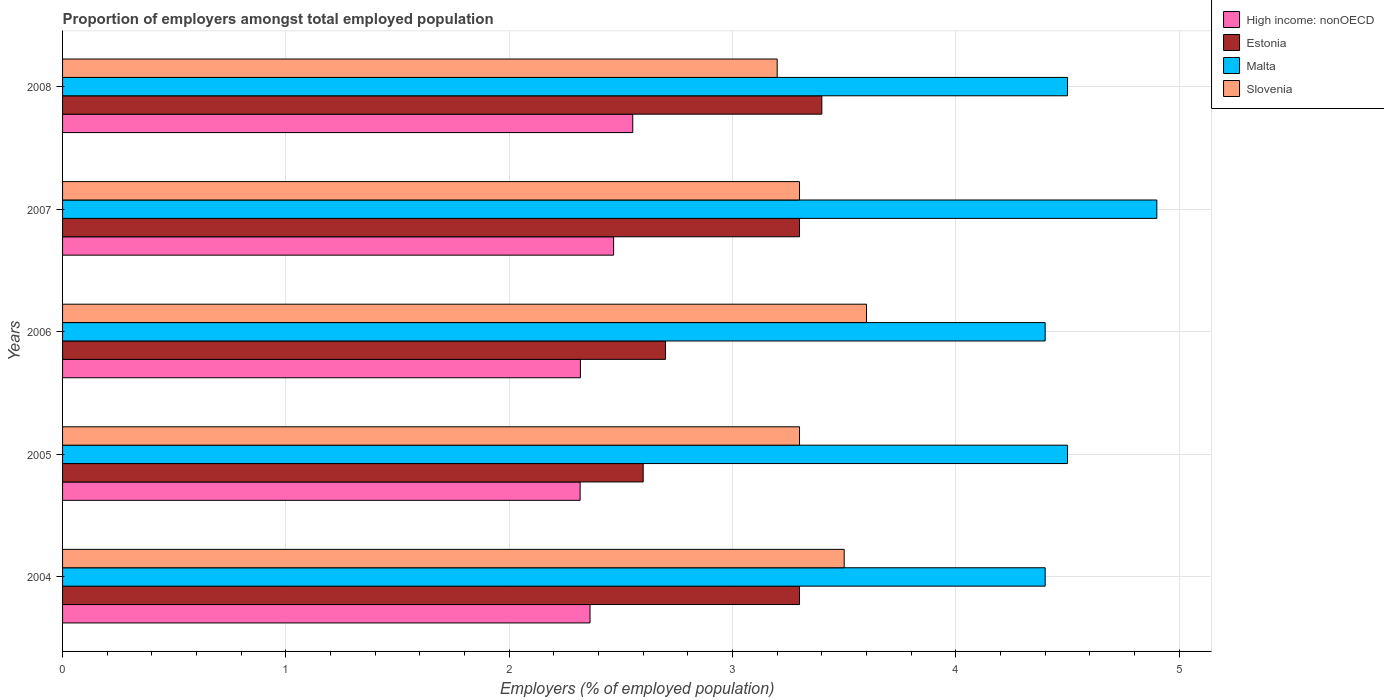Are the number of bars per tick equal to the number of legend labels?
Provide a short and direct response. Yes. Are the number of bars on each tick of the Y-axis equal?
Your answer should be very brief. Yes. How many bars are there on the 3rd tick from the top?
Offer a very short reply. 4. What is the label of the 5th group of bars from the top?
Make the answer very short. 2004. What is the proportion of employers in Slovenia in 2007?
Your response must be concise. 3.3. Across all years, what is the maximum proportion of employers in Estonia?
Offer a very short reply. 3.4. Across all years, what is the minimum proportion of employers in Slovenia?
Ensure brevity in your answer.  3.2. What is the total proportion of employers in Slovenia in the graph?
Give a very brief answer. 16.9. What is the difference between the proportion of employers in Slovenia in 2005 and that in 2008?
Make the answer very short. 0.1. What is the difference between the proportion of employers in Malta in 2008 and the proportion of employers in Estonia in 2007?
Your answer should be compact. 1.2. What is the average proportion of employers in Estonia per year?
Give a very brief answer. 3.06. In the year 2004, what is the difference between the proportion of employers in High income: nonOECD and proportion of employers in Estonia?
Provide a short and direct response. -0.94. In how many years, is the proportion of employers in Malta greater than 4 %?
Offer a terse response. 5. What is the ratio of the proportion of employers in Estonia in 2006 to that in 2007?
Make the answer very short. 0.82. Is the difference between the proportion of employers in High income: nonOECD in 2007 and 2008 greater than the difference between the proportion of employers in Estonia in 2007 and 2008?
Offer a terse response. Yes. What is the difference between the highest and the second highest proportion of employers in Malta?
Provide a succinct answer. 0.4. What is the difference between the highest and the lowest proportion of employers in Estonia?
Provide a succinct answer. 0.8. Is the sum of the proportion of employers in Malta in 2004 and 2007 greater than the maximum proportion of employers in Slovenia across all years?
Provide a short and direct response. Yes. What does the 2nd bar from the top in 2007 represents?
Provide a succinct answer. Malta. What does the 4th bar from the bottom in 2008 represents?
Keep it short and to the point. Slovenia. How many bars are there?
Provide a succinct answer. 20. What is the difference between two consecutive major ticks on the X-axis?
Provide a succinct answer. 1. Are the values on the major ticks of X-axis written in scientific E-notation?
Your answer should be compact. No. Does the graph contain grids?
Keep it short and to the point. Yes. Where does the legend appear in the graph?
Offer a terse response. Top right. How many legend labels are there?
Your answer should be very brief. 4. How are the legend labels stacked?
Your answer should be very brief. Vertical. What is the title of the graph?
Offer a terse response. Proportion of employers amongst total employed population. What is the label or title of the X-axis?
Offer a terse response. Employers (% of employed population). What is the Employers (% of employed population) in High income: nonOECD in 2004?
Your answer should be very brief. 2.36. What is the Employers (% of employed population) in Estonia in 2004?
Provide a short and direct response. 3.3. What is the Employers (% of employed population) of Malta in 2004?
Offer a very short reply. 4.4. What is the Employers (% of employed population) of High income: nonOECD in 2005?
Give a very brief answer. 2.32. What is the Employers (% of employed population) of Estonia in 2005?
Give a very brief answer. 2.6. What is the Employers (% of employed population) in Slovenia in 2005?
Offer a very short reply. 3.3. What is the Employers (% of employed population) in High income: nonOECD in 2006?
Keep it short and to the point. 2.32. What is the Employers (% of employed population) in Estonia in 2006?
Your answer should be compact. 2.7. What is the Employers (% of employed population) in Malta in 2006?
Your answer should be very brief. 4.4. What is the Employers (% of employed population) of Slovenia in 2006?
Make the answer very short. 3.6. What is the Employers (% of employed population) in High income: nonOECD in 2007?
Offer a very short reply. 2.47. What is the Employers (% of employed population) in Estonia in 2007?
Provide a short and direct response. 3.3. What is the Employers (% of employed population) of Malta in 2007?
Make the answer very short. 4.9. What is the Employers (% of employed population) in Slovenia in 2007?
Make the answer very short. 3.3. What is the Employers (% of employed population) of High income: nonOECD in 2008?
Your answer should be very brief. 2.55. What is the Employers (% of employed population) of Estonia in 2008?
Your answer should be compact. 3.4. What is the Employers (% of employed population) of Malta in 2008?
Make the answer very short. 4.5. What is the Employers (% of employed population) in Slovenia in 2008?
Give a very brief answer. 3.2. Across all years, what is the maximum Employers (% of employed population) in High income: nonOECD?
Your answer should be very brief. 2.55. Across all years, what is the maximum Employers (% of employed population) in Estonia?
Your response must be concise. 3.4. Across all years, what is the maximum Employers (% of employed population) of Malta?
Your response must be concise. 4.9. Across all years, what is the maximum Employers (% of employed population) in Slovenia?
Your answer should be very brief. 3.6. Across all years, what is the minimum Employers (% of employed population) in High income: nonOECD?
Keep it short and to the point. 2.32. Across all years, what is the minimum Employers (% of employed population) of Estonia?
Offer a very short reply. 2.6. Across all years, what is the minimum Employers (% of employed population) of Malta?
Your answer should be compact. 4.4. Across all years, what is the minimum Employers (% of employed population) in Slovenia?
Make the answer very short. 3.2. What is the total Employers (% of employed population) of High income: nonOECD in the graph?
Make the answer very short. 12.02. What is the total Employers (% of employed population) of Malta in the graph?
Your response must be concise. 22.7. What is the total Employers (% of employed population) in Slovenia in the graph?
Offer a very short reply. 16.9. What is the difference between the Employers (% of employed population) of High income: nonOECD in 2004 and that in 2005?
Ensure brevity in your answer.  0.04. What is the difference between the Employers (% of employed population) in Estonia in 2004 and that in 2005?
Offer a terse response. 0.7. What is the difference between the Employers (% of employed population) of Slovenia in 2004 and that in 2005?
Offer a terse response. 0.2. What is the difference between the Employers (% of employed population) in High income: nonOECD in 2004 and that in 2006?
Ensure brevity in your answer.  0.04. What is the difference between the Employers (% of employed population) in Malta in 2004 and that in 2006?
Your answer should be very brief. 0. What is the difference between the Employers (% of employed population) of High income: nonOECD in 2004 and that in 2007?
Offer a very short reply. -0.11. What is the difference between the Employers (% of employed population) in Slovenia in 2004 and that in 2007?
Your answer should be very brief. 0.2. What is the difference between the Employers (% of employed population) in High income: nonOECD in 2004 and that in 2008?
Give a very brief answer. -0.19. What is the difference between the Employers (% of employed population) in Malta in 2004 and that in 2008?
Provide a succinct answer. -0.1. What is the difference between the Employers (% of employed population) in Slovenia in 2004 and that in 2008?
Provide a succinct answer. 0.3. What is the difference between the Employers (% of employed population) of High income: nonOECD in 2005 and that in 2006?
Your response must be concise. -0. What is the difference between the Employers (% of employed population) of Estonia in 2005 and that in 2006?
Give a very brief answer. -0.1. What is the difference between the Employers (% of employed population) of Slovenia in 2005 and that in 2006?
Provide a succinct answer. -0.3. What is the difference between the Employers (% of employed population) of High income: nonOECD in 2005 and that in 2007?
Keep it short and to the point. -0.15. What is the difference between the Employers (% of employed population) in Slovenia in 2005 and that in 2007?
Provide a succinct answer. 0. What is the difference between the Employers (% of employed population) of High income: nonOECD in 2005 and that in 2008?
Offer a very short reply. -0.24. What is the difference between the Employers (% of employed population) of Malta in 2005 and that in 2008?
Offer a very short reply. 0. What is the difference between the Employers (% of employed population) of Slovenia in 2005 and that in 2008?
Keep it short and to the point. 0.1. What is the difference between the Employers (% of employed population) of High income: nonOECD in 2006 and that in 2007?
Keep it short and to the point. -0.15. What is the difference between the Employers (% of employed population) in Slovenia in 2006 and that in 2007?
Ensure brevity in your answer.  0.3. What is the difference between the Employers (% of employed population) of High income: nonOECD in 2006 and that in 2008?
Your response must be concise. -0.23. What is the difference between the Employers (% of employed population) in Estonia in 2006 and that in 2008?
Make the answer very short. -0.7. What is the difference between the Employers (% of employed population) of Malta in 2006 and that in 2008?
Ensure brevity in your answer.  -0.1. What is the difference between the Employers (% of employed population) of High income: nonOECD in 2007 and that in 2008?
Provide a succinct answer. -0.09. What is the difference between the Employers (% of employed population) of Malta in 2007 and that in 2008?
Keep it short and to the point. 0.4. What is the difference between the Employers (% of employed population) in Slovenia in 2007 and that in 2008?
Ensure brevity in your answer.  0.1. What is the difference between the Employers (% of employed population) in High income: nonOECD in 2004 and the Employers (% of employed population) in Estonia in 2005?
Offer a very short reply. -0.24. What is the difference between the Employers (% of employed population) in High income: nonOECD in 2004 and the Employers (% of employed population) in Malta in 2005?
Make the answer very short. -2.14. What is the difference between the Employers (% of employed population) in High income: nonOECD in 2004 and the Employers (% of employed population) in Slovenia in 2005?
Your answer should be very brief. -0.94. What is the difference between the Employers (% of employed population) of Estonia in 2004 and the Employers (% of employed population) of Slovenia in 2005?
Give a very brief answer. 0. What is the difference between the Employers (% of employed population) in High income: nonOECD in 2004 and the Employers (% of employed population) in Estonia in 2006?
Your response must be concise. -0.34. What is the difference between the Employers (% of employed population) in High income: nonOECD in 2004 and the Employers (% of employed population) in Malta in 2006?
Offer a very short reply. -2.04. What is the difference between the Employers (% of employed population) of High income: nonOECD in 2004 and the Employers (% of employed population) of Slovenia in 2006?
Offer a very short reply. -1.24. What is the difference between the Employers (% of employed population) in Estonia in 2004 and the Employers (% of employed population) in Malta in 2006?
Your response must be concise. -1.1. What is the difference between the Employers (% of employed population) of High income: nonOECD in 2004 and the Employers (% of employed population) of Estonia in 2007?
Ensure brevity in your answer.  -0.94. What is the difference between the Employers (% of employed population) of High income: nonOECD in 2004 and the Employers (% of employed population) of Malta in 2007?
Your answer should be very brief. -2.54. What is the difference between the Employers (% of employed population) in High income: nonOECD in 2004 and the Employers (% of employed population) in Slovenia in 2007?
Make the answer very short. -0.94. What is the difference between the Employers (% of employed population) in Estonia in 2004 and the Employers (% of employed population) in Malta in 2007?
Your answer should be very brief. -1.6. What is the difference between the Employers (% of employed population) in Malta in 2004 and the Employers (% of employed population) in Slovenia in 2007?
Offer a terse response. 1.1. What is the difference between the Employers (% of employed population) in High income: nonOECD in 2004 and the Employers (% of employed population) in Estonia in 2008?
Provide a succinct answer. -1.04. What is the difference between the Employers (% of employed population) in High income: nonOECD in 2004 and the Employers (% of employed population) in Malta in 2008?
Provide a short and direct response. -2.14. What is the difference between the Employers (% of employed population) in High income: nonOECD in 2004 and the Employers (% of employed population) in Slovenia in 2008?
Provide a succinct answer. -0.84. What is the difference between the Employers (% of employed population) of Estonia in 2004 and the Employers (% of employed population) of Slovenia in 2008?
Offer a very short reply. 0.1. What is the difference between the Employers (% of employed population) in High income: nonOECD in 2005 and the Employers (% of employed population) in Estonia in 2006?
Make the answer very short. -0.38. What is the difference between the Employers (% of employed population) in High income: nonOECD in 2005 and the Employers (% of employed population) in Malta in 2006?
Offer a terse response. -2.08. What is the difference between the Employers (% of employed population) in High income: nonOECD in 2005 and the Employers (% of employed population) in Slovenia in 2006?
Keep it short and to the point. -1.28. What is the difference between the Employers (% of employed population) of Estonia in 2005 and the Employers (% of employed population) of Slovenia in 2006?
Your answer should be very brief. -1. What is the difference between the Employers (% of employed population) of High income: nonOECD in 2005 and the Employers (% of employed population) of Estonia in 2007?
Ensure brevity in your answer.  -0.98. What is the difference between the Employers (% of employed population) in High income: nonOECD in 2005 and the Employers (% of employed population) in Malta in 2007?
Your answer should be very brief. -2.58. What is the difference between the Employers (% of employed population) of High income: nonOECD in 2005 and the Employers (% of employed population) of Slovenia in 2007?
Give a very brief answer. -0.98. What is the difference between the Employers (% of employed population) in Estonia in 2005 and the Employers (% of employed population) in Slovenia in 2007?
Ensure brevity in your answer.  -0.7. What is the difference between the Employers (% of employed population) of Malta in 2005 and the Employers (% of employed population) of Slovenia in 2007?
Offer a terse response. 1.2. What is the difference between the Employers (% of employed population) of High income: nonOECD in 2005 and the Employers (% of employed population) of Estonia in 2008?
Keep it short and to the point. -1.08. What is the difference between the Employers (% of employed population) of High income: nonOECD in 2005 and the Employers (% of employed population) of Malta in 2008?
Offer a terse response. -2.18. What is the difference between the Employers (% of employed population) of High income: nonOECD in 2005 and the Employers (% of employed population) of Slovenia in 2008?
Offer a very short reply. -0.88. What is the difference between the Employers (% of employed population) in Estonia in 2005 and the Employers (% of employed population) in Slovenia in 2008?
Keep it short and to the point. -0.6. What is the difference between the Employers (% of employed population) of High income: nonOECD in 2006 and the Employers (% of employed population) of Estonia in 2007?
Offer a terse response. -0.98. What is the difference between the Employers (% of employed population) of High income: nonOECD in 2006 and the Employers (% of employed population) of Malta in 2007?
Offer a very short reply. -2.58. What is the difference between the Employers (% of employed population) in High income: nonOECD in 2006 and the Employers (% of employed population) in Slovenia in 2007?
Ensure brevity in your answer.  -0.98. What is the difference between the Employers (% of employed population) of Estonia in 2006 and the Employers (% of employed population) of Malta in 2007?
Offer a terse response. -2.2. What is the difference between the Employers (% of employed population) of Estonia in 2006 and the Employers (% of employed population) of Slovenia in 2007?
Your response must be concise. -0.6. What is the difference between the Employers (% of employed population) in High income: nonOECD in 2006 and the Employers (% of employed population) in Estonia in 2008?
Your answer should be compact. -1.08. What is the difference between the Employers (% of employed population) of High income: nonOECD in 2006 and the Employers (% of employed population) of Malta in 2008?
Offer a terse response. -2.18. What is the difference between the Employers (% of employed population) in High income: nonOECD in 2006 and the Employers (% of employed population) in Slovenia in 2008?
Offer a very short reply. -0.88. What is the difference between the Employers (% of employed population) of Estonia in 2006 and the Employers (% of employed population) of Malta in 2008?
Your response must be concise. -1.8. What is the difference between the Employers (% of employed population) of Malta in 2006 and the Employers (% of employed population) of Slovenia in 2008?
Provide a succinct answer. 1.2. What is the difference between the Employers (% of employed population) in High income: nonOECD in 2007 and the Employers (% of employed population) in Estonia in 2008?
Provide a short and direct response. -0.93. What is the difference between the Employers (% of employed population) in High income: nonOECD in 2007 and the Employers (% of employed population) in Malta in 2008?
Make the answer very short. -2.03. What is the difference between the Employers (% of employed population) of High income: nonOECD in 2007 and the Employers (% of employed population) of Slovenia in 2008?
Make the answer very short. -0.73. What is the difference between the Employers (% of employed population) in Estonia in 2007 and the Employers (% of employed population) in Malta in 2008?
Make the answer very short. -1.2. What is the difference between the Employers (% of employed population) of Estonia in 2007 and the Employers (% of employed population) of Slovenia in 2008?
Give a very brief answer. 0.1. What is the difference between the Employers (% of employed population) in Malta in 2007 and the Employers (% of employed population) in Slovenia in 2008?
Keep it short and to the point. 1.7. What is the average Employers (% of employed population) of High income: nonOECD per year?
Keep it short and to the point. 2.4. What is the average Employers (% of employed population) of Estonia per year?
Your response must be concise. 3.06. What is the average Employers (% of employed population) of Malta per year?
Make the answer very short. 4.54. What is the average Employers (% of employed population) in Slovenia per year?
Provide a short and direct response. 3.38. In the year 2004, what is the difference between the Employers (% of employed population) of High income: nonOECD and Employers (% of employed population) of Estonia?
Make the answer very short. -0.94. In the year 2004, what is the difference between the Employers (% of employed population) of High income: nonOECD and Employers (% of employed population) of Malta?
Provide a succinct answer. -2.04. In the year 2004, what is the difference between the Employers (% of employed population) of High income: nonOECD and Employers (% of employed population) of Slovenia?
Your response must be concise. -1.14. In the year 2004, what is the difference between the Employers (% of employed population) of Estonia and Employers (% of employed population) of Malta?
Your answer should be very brief. -1.1. In the year 2005, what is the difference between the Employers (% of employed population) in High income: nonOECD and Employers (% of employed population) in Estonia?
Offer a terse response. -0.28. In the year 2005, what is the difference between the Employers (% of employed population) in High income: nonOECD and Employers (% of employed population) in Malta?
Your answer should be very brief. -2.18. In the year 2005, what is the difference between the Employers (% of employed population) in High income: nonOECD and Employers (% of employed population) in Slovenia?
Your response must be concise. -0.98. In the year 2005, what is the difference between the Employers (% of employed population) in Malta and Employers (% of employed population) in Slovenia?
Your answer should be compact. 1.2. In the year 2006, what is the difference between the Employers (% of employed population) of High income: nonOECD and Employers (% of employed population) of Estonia?
Offer a terse response. -0.38. In the year 2006, what is the difference between the Employers (% of employed population) in High income: nonOECD and Employers (% of employed population) in Malta?
Provide a succinct answer. -2.08. In the year 2006, what is the difference between the Employers (% of employed population) of High income: nonOECD and Employers (% of employed population) of Slovenia?
Your response must be concise. -1.28. In the year 2006, what is the difference between the Employers (% of employed population) in Estonia and Employers (% of employed population) in Slovenia?
Your answer should be compact. -0.9. In the year 2007, what is the difference between the Employers (% of employed population) in High income: nonOECD and Employers (% of employed population) in Estonia?
Provide a short and direct response. -0.83. In the year 2007, what is the difference between the Employers (% of employed population) of High income: nonOECD and Employers (% of employed population) of Malta?
Provide a short and direct response. -2.43. In the year 2007, what is the difference between the Employers (% of employed population) in High income: nonOECD and Employers (% of employed population) in Slovenia?
Make the answer very short. -0.83. In the year 2007, what is the difference between the Employers (% of employed population) in Estonia and Employers (% of employed population) in Malta?
Your response must be concise. -1.6. In the year 2007, what is the difference between the Employers (% of employed population) of Malta and Employers (% of employed population) of Slovenia?
Make the answer very short. 1.6. In the year 2008, what is the difference between the Employers (% of employed population) of High income: nonOECD and Employers (% of employed population) of Estonia?
Provide a short and direct response. -0.85. In the year 2008, what is the difference between the Employers (% of employed population) of High income: nonOECD and Employers (% of employed population) of Malta?
Make the answer very short. -1.95. In the year 2008, what is the difference between the Employers (% of employed population) of High income: nonOECD and Employers (% of employed population) of Slovenia?
Ensure brevity in your answer.  -0.65. In the year 2008, what is the difference between the Employers (% of employed population) in Malta and Employers (% of employed population) in Slovenia?
Your answer should be very brief. 1.3. What is the ratio of the Employers (% of employed population) of High income: nonOECD in 2004 to that in 2005?
Provide a succinct answer. 1.02. What is the ratio of the Employers (% of employed population) of Estonia in 2004 to that in 2005?
Provide a succinct answer. 1.27. What is the ratio of the Employers (% of employed population) of Malta in 2004 to that in 2005?
Provide a succinct answer. 0.98. What is the ratio of the Employers (% of employed population) in Slovenia in 2004 to that in 2005?
Your response must be concise. 1.06. What is the ratio of the Employers (% of employed population) of High income: nonOECD in 2004 to that in 2006?
Offer a very short reply. 1.02. What is the ratio of the Employers (% of employed population) in Estonia in 2004 to that in 2006?
Keep it short and to the point. 1.22. What is the ratio of the Employers (% of employed population) in Malta in 2004 to that in 2006?
Ensure brevity in your answer.  1. What is the ratio of the Employers (% of employed population) in Slovenia in 2004 to that in 2006?
Your answer should be compact. 0.97. What is the ratio of the Employers (% of employed population) in High income: nonOECD in 2004 to that in 2007?
Offer a very short reply. 0.96. What is the ratio of the Employers (% of employed population) of Estonia in 2004 to that in 2007?
Your answer should be very brief. 1. What is the ratio of the Employers (% of employed population) in Malta in 2004 to that in 2007?
Make the answer very short. 0.9. What is the ratio of the Employers (% of employed population) of Slovenia in 2004 to that in 2007?
Provide a short and direct response. 1.06. What is the ratio of the Employers (% of employed population) in High income: nonOECD in 2004 to that in 2008?
Your answer should be compact. 0.93. What is the ratio of the Employers (% of employed population) of Estonia in 2004 to that in 2008?
Keep it short and to the point. 0.97. What is the ratio of the Employers (% of employed population) of Malta in 2004 to that in 2008?
Keep it short and to the point. 0.98. What is the ratio of the Employers (% of employed population) of Slovenia in 2004 to that in 2008?
Offer a very short reply. 1.09. What is the ratio of the Employers (% of employed population) in Malta in 2005 to that in 2006?
Your answer should be compact. 1.02. What is the ratio of the Employers (% of employed population) in High income: nonOECD in 2005 to that in 2007?
Provide a short and direct response. 0.94. What is the ratio of the Employers (% of employed population) of Estonia in 2005 to that in 2007?
Offer a very short reply. 0.79. What is the ratio of the Employers (% of employed population) of Malta in 2005 to that in 2007?
Provide a succinct answer. 0.92. What is the ratio of the Employers (% of employed population) of Slovenia in 2005 to that in 2007?
Your answer should be very brief. 1. What is the ratio of the Employers (% of employed population) in High income: nonOECD in 2005 to that in 2008?
Your response must be concise. 0.91. What is the ratio of the Employers (% of employed population) of Estonia in 2005 to that in 2008?
Make the answer very short. 0.76. What is the ratio of the Employers (% of employed population) in Slovenia in 2005 to that in 2008?
Your response must be concise. 1.03. What is the ratio of the Employers (% of employed population) in High income: nonOECD in 2006 to that in 2007?
Provide a succinct answer. 0.94. What is the ratio of the Employers (% of employed population) in Estonia in 2006 to that in 2007?
Give a very brief answer. 0.82. What is the ratio of the Employers (% of employed population) in Malta in 2006 to that in 2007?
Keep it short and to the point. 0.9. What is the ratio of the Employers (% of employed population) in Slovenia in 2006 to that in 2007?
Offer a very short reply. 1.09. What is the ratio of the Employers (% of employed population) in High income: nonOECD in 2006 to that in 2008?
Make the answer very short. 0.91. What is the ratio of the Employers (% of employed population) of Estonia in 2006 to that in 2008?
Ensure brevity in your answer.  0.79. What is the ratio of the Employers (% of employed population) in Malta in 2006 to that in 2008?
Your answer should be very brief. 0.98. What is the ratio of the Employers (% of employed population) in High income: nonOECD in 2007 to that in 2008?
Offer a very short reply. 0.97. What is the ratio of the Employers (% of employed population) of Estonia in 2007 to that in 2008?
Your answer should be compact. 0.97. What is the ratio of the Employers (% of employed population) of Malta in 2007 to that in 2008?
Your answer should be very brief. 1.09. What is the ratio of the Employers (% of employed population) in Slovenia in 2007 to that in 2008?
Offer a very short reply. 1.03. What is the difference between the highest and the second highest Employers (% of employed population) in High income: nonOECD?
Your answer should be compact. 0.09. What is the difference between the highest and the lowest Employers (% of employed population) of High income: nonOECD?
Offer a terse response. 0.24. What is the difference between the highest and the lowest Employers (% of employed population) in Malta?
Your response must be concise. 0.5. 